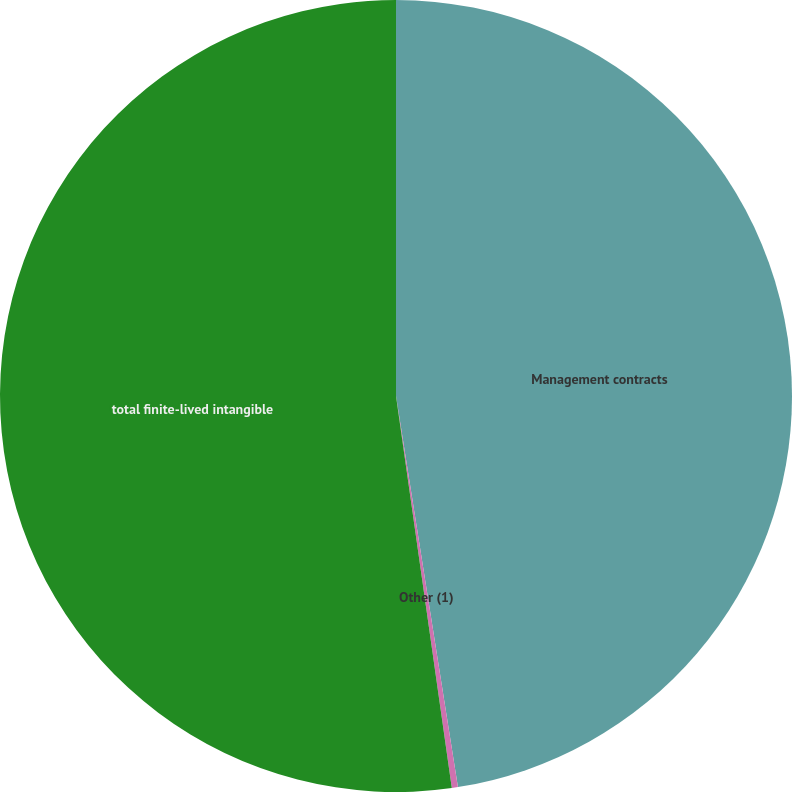Convert chart to OTSL. <chart><loc_0><loc_0><loc_500><loc_500><pie_chart><fcel>Management contracts<fcel>Other (1)<fcel>total finite-lived intangible<nl><fcel>47.5%<fcel>0.25%<fcel>52.25%<nl></chart> 